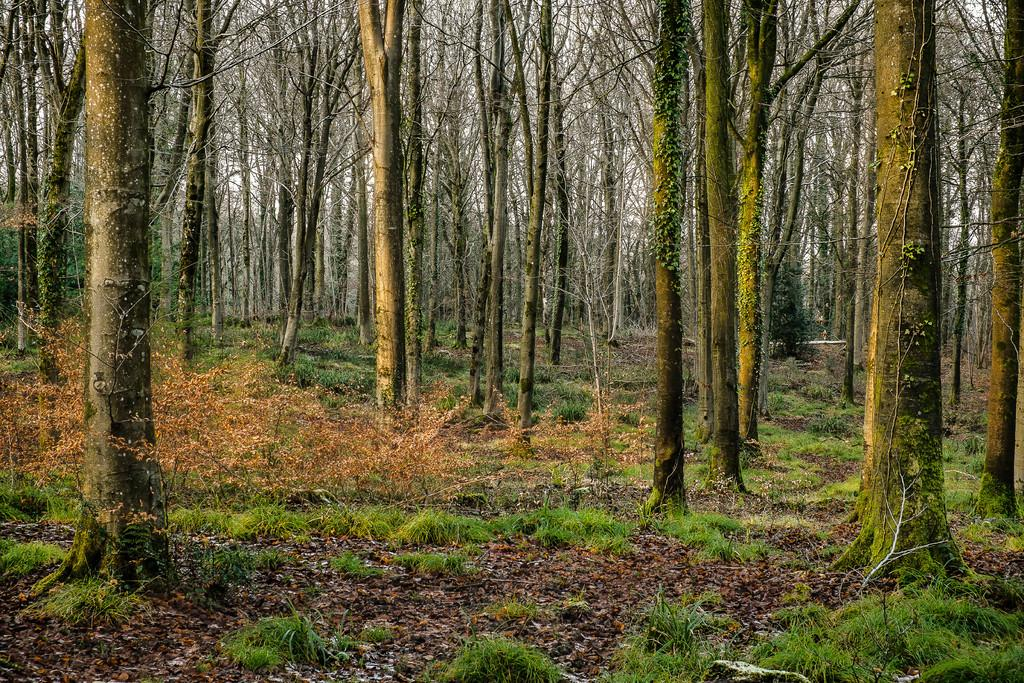What type of terrain is visible at the bottom of the image? There is a grassy land at the bottom of the image. What can be seen in the background of the image? There are trees in the background of the image. How does the zephyr affect the woman and plant in the image? There is no woman or plant present in the image, and therefore no zephyr can be observed affecting them. 